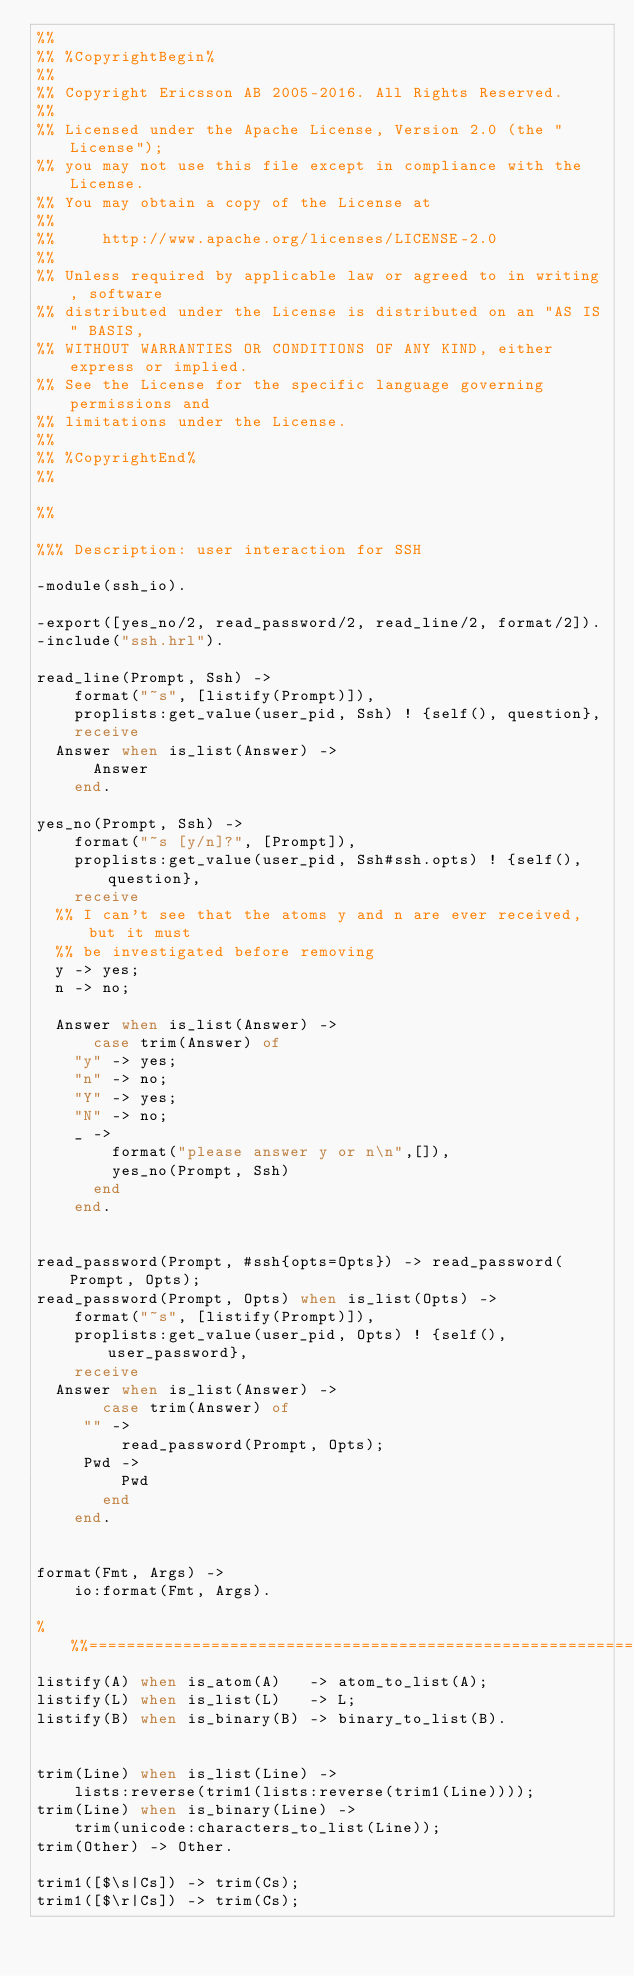<code> <loc_0><loc_0><loc_500><loc_500><_Erlang_>%%
%% %CopyrightBegin%
%%
%% Copyright Ericsson AB 2005-2016. All Rights Reserved.
%%
%% Licensed under the Apache License, Version 2.0 (the "License");
%% you may not use this file except in compliance with the License.
%% You may obtain a copy of the License at
%%
%%     http://www.apache.org/licenses/LICENSE-2.0
%%
%% Unless required by applicable law or agreed to in writing, software
%% distributed under the License is distributed on an "AS IS" BASIS,
%% WITHOUT WARRANTIES OR CONDITIONS OF ANY KIND, either express or implied.
%% See the License for the specific language governing permissions and
%% limitations under the License.
%%
%% %CopyrightEnd%
%%

%%

%%% Description: user interaction for SSH

-module(ssh_io).

-export([yes_no/2, read_password/2, read_line/2, format/2]).
-include("ssh.hrl").

read_line(Prompt, Ssh) ->
    format("~s", [listify(Prompt)]),
    proplists:get_value(user_pid, Ssh) ! {self(), question},
    receive
	Answer when is_list(Answer) ->
	    Answer
    end.

yes_no(Prompt, Ssh) ->
    format("~s [y/n]?", [Prompt]),
    proplists:get_value(user_pid, Ssh#ssh.opts) ! {self(), question},
    receive
	%% I can't see that the atoms y and n are ever received, but it must
	%% be investigated before removing
	y -> yes;
	n -> no;

	Answer when is_list(Answer) ->
	    case trim(Answer) of
		"y" -> yes;
		"n" -> no;
		"Y" -> yes;
		"N" -> no;
		_ ->
		    format("please answer y or n\n",[]),
		    yes_no(Prompt, Ssh)
	    end
    end.


read_password(Prompt, #ssh{opts=Opts}) -> read_password(Prompt, Opts);
read_password(Prompt, Opts) when is_list(Opts) ->
    format("~s", [listify(Prompt)]),
    proplists:get_value(user_pid, Opts) ! {self(), user_password},
    receive
	Answer when is_list(Answer) ->
	     case trim(Answer) of
		 "" ->
		     read_password(Prompt, Opts);
		 Pwd ->
		     Pwd
	     end
    end.


format(Fmt, Args) ->
    io:format(Fmt, Args).

%%%================================================================
listify(A) when is_atom(A)   -> atom_to_list(A);
listify(L) when is_list(L)   -> L;
listify(B) when is_binary(B) -> binary_to_list(B).


trim(Line) when is_list(Line) ->
    lists:reverse(trim1(lists:reverse(trim1(Line))));
trim(Line) when is_binary(Line) ->
    trim(unicode:characters_to_list(Line));
trim(Other) -> Other.

trim1([$\s|Cs]) -> trim(Cs);
trim1([$\r|Cs]) -> trim(Cs);</code> 